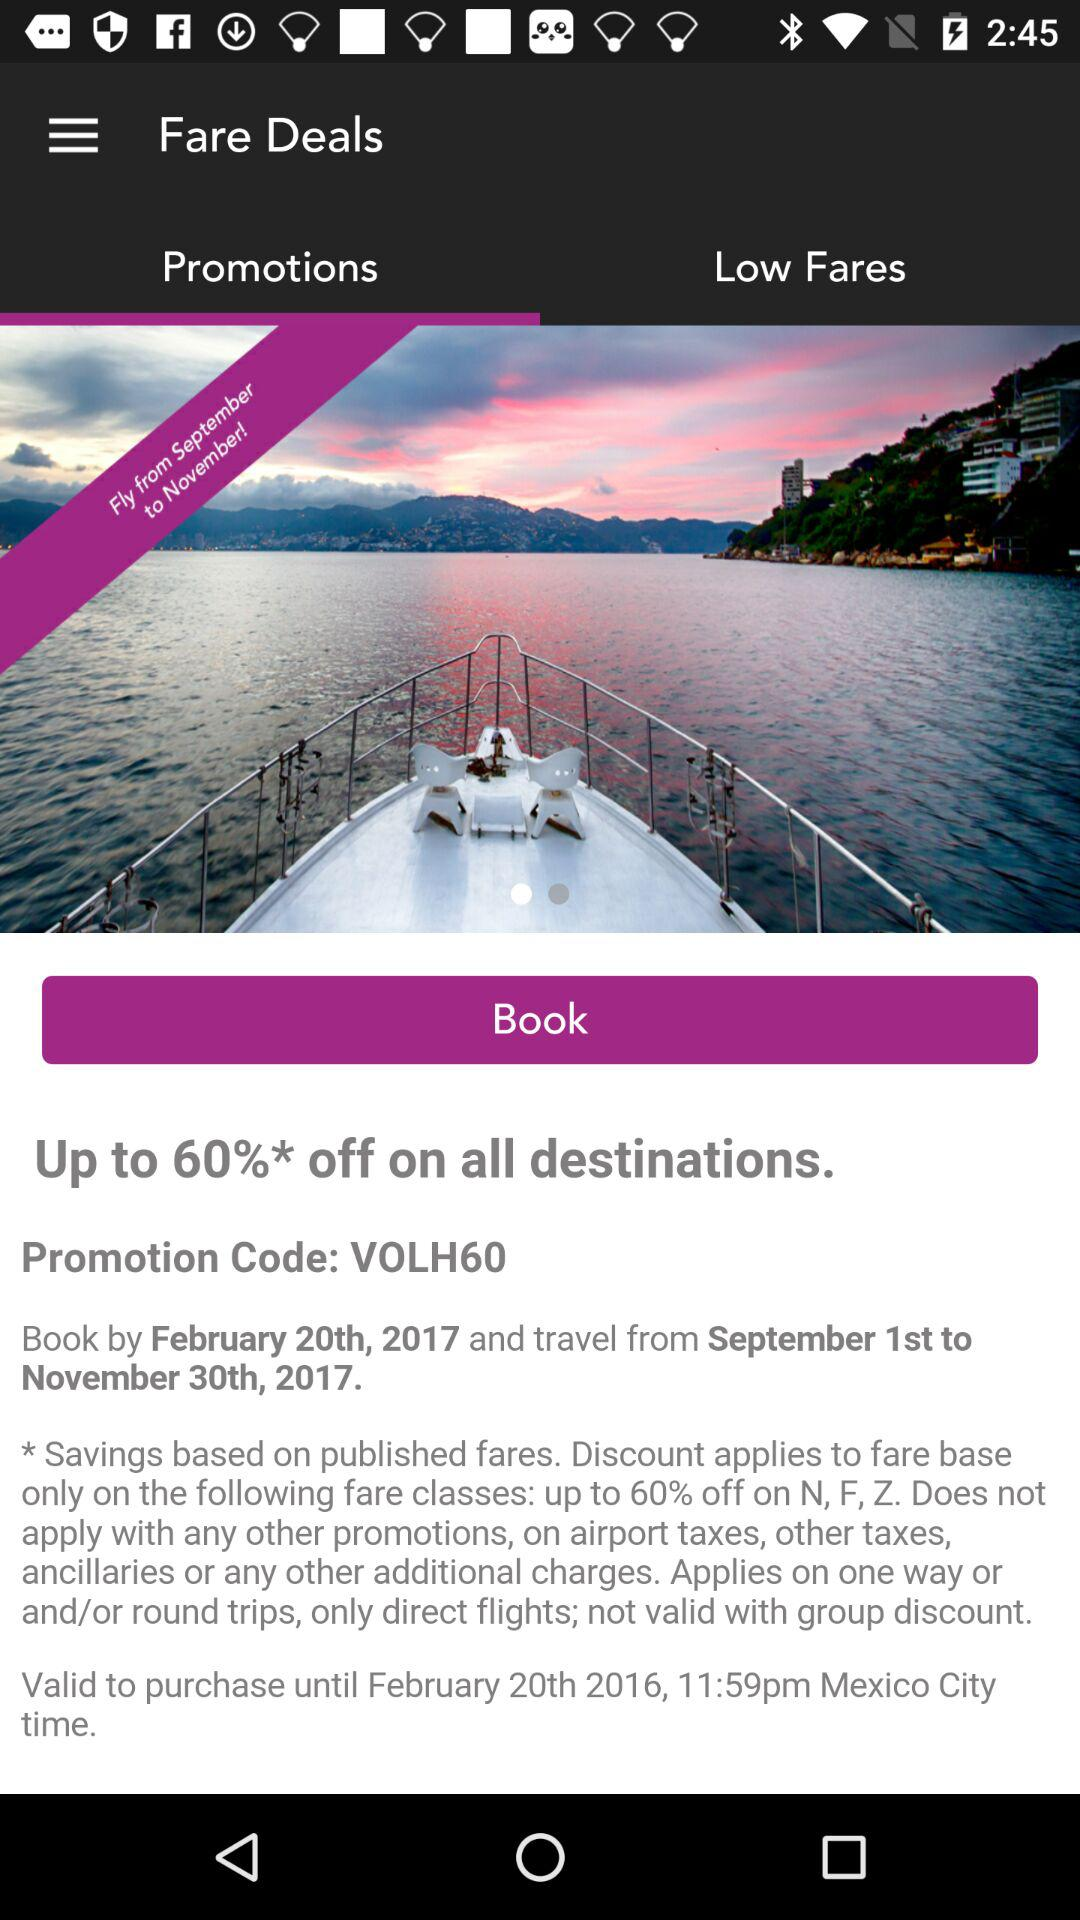On which classes is the discount available? The discount is available on N, F and Z classes. 